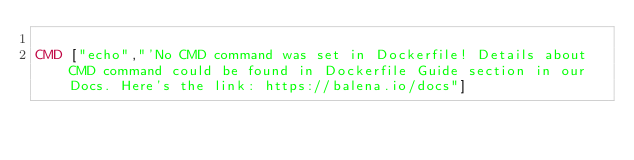<code> <loc_0><loc_0><loc_500><loc_500><_Dockerfile_>
CMD ["echo","'No CMD command was set in Dockerfile! Details about CMD command could be found in Dockerfile Guide section in our Docs. Here's the link: https://balena.io/docs"]
</code> 